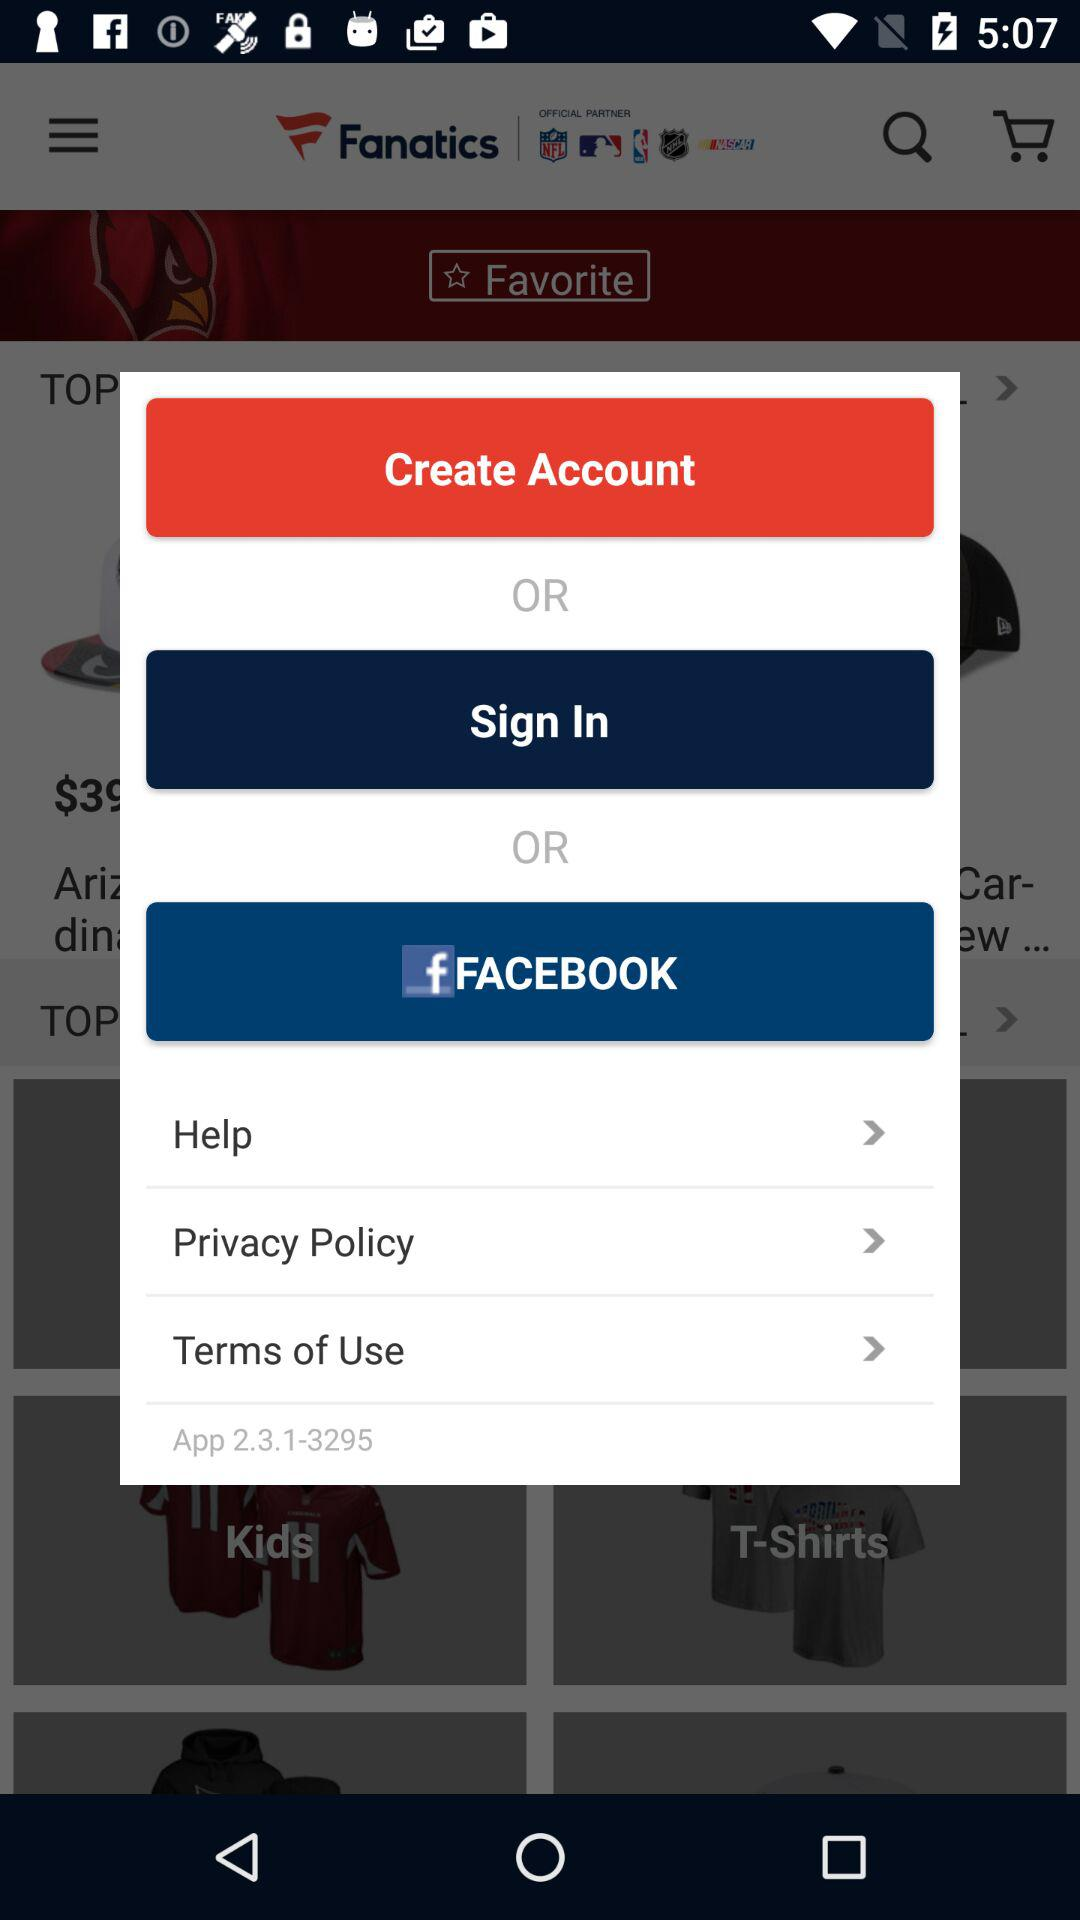What application is used for sign in? The application is "Facebook". 